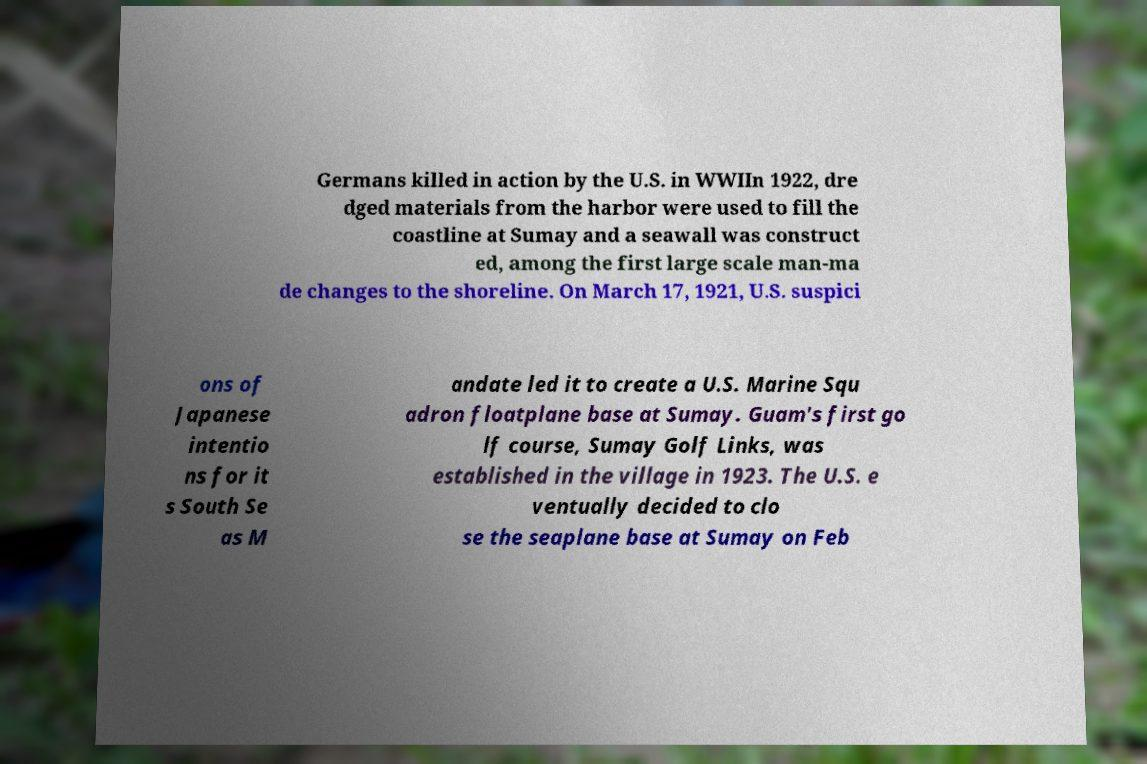There's text embedded in this image that I need extracted. Can you transcribe it verbatim? Germans killed in action by the U.S. in WWIIn 1922, dre dged materials from the harbor were used to fill the coastline at Sumay and a seawall was construct ed, among the first large scale man-ma de changes to the shoreline. On March 17, 1921, U.S. suspici ons of Japanese intentio ns for it s South Se as M andate led it to create a U.S. Marine Squ adron floatplane base at Sumay. Guam's first go lf course, Sumay Golf Links, was established in the village in 1923. The U.S. e ventually decided to clo se the seaplane base at Sumay on Feb 